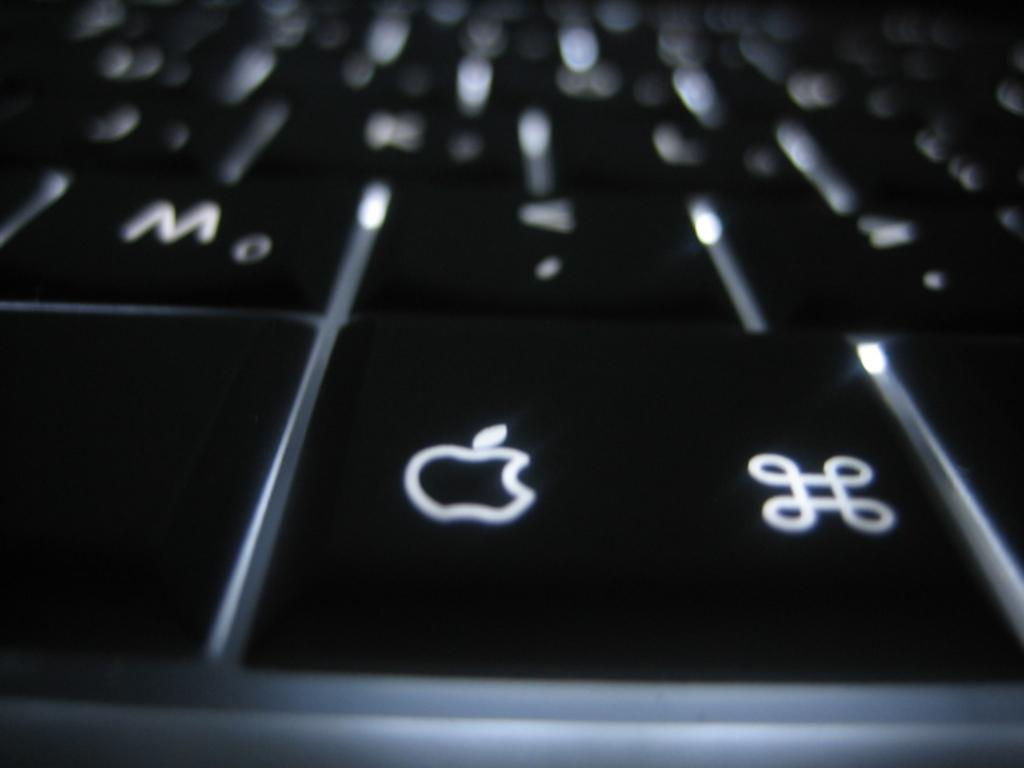What type of keys are visible in the image? The image contains keyboard keys. Can you describe a specific key in the image? There is a black key with an apple product logo on it. What type of alarm can be heard going off in the image? There is no alarm present in the image, as it is a still image of keyboard keys. 